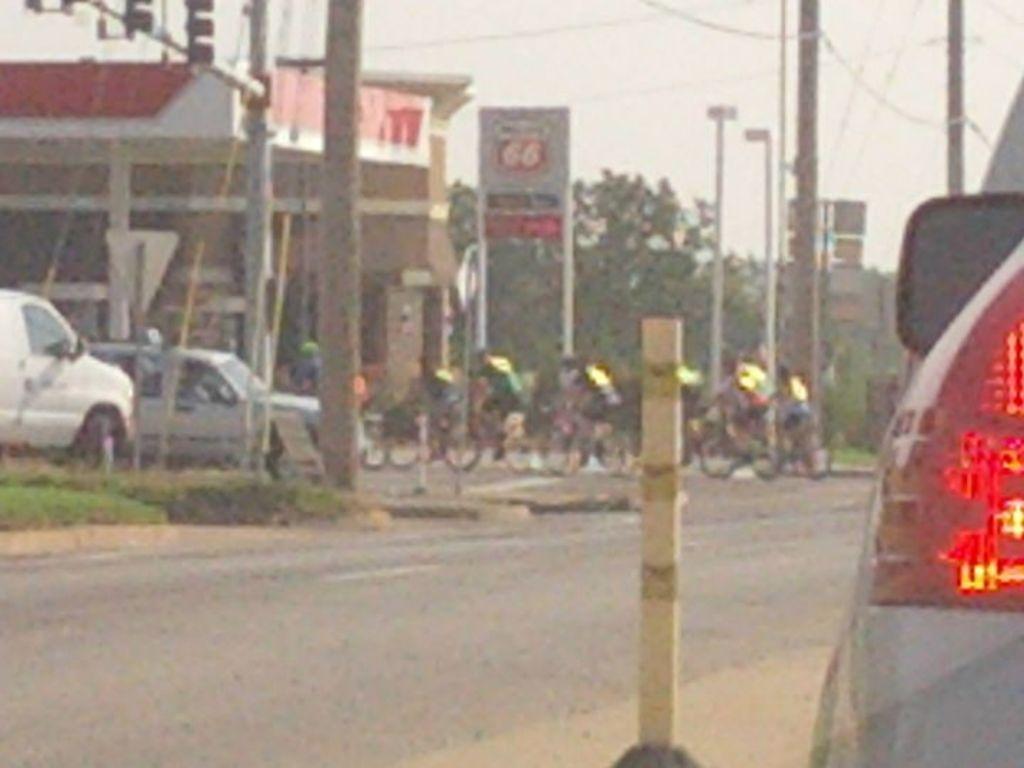Could you give a brief overview of what you see in this image? In this picture we can see a group of people riding bicycles on the road. On the left side of the road, there are poles, a board and cables. On the left and right side of the image, there are vehicles. Behind the people, there are trees, a building and the sky. At the bottom of the image, there is a lane pole. 